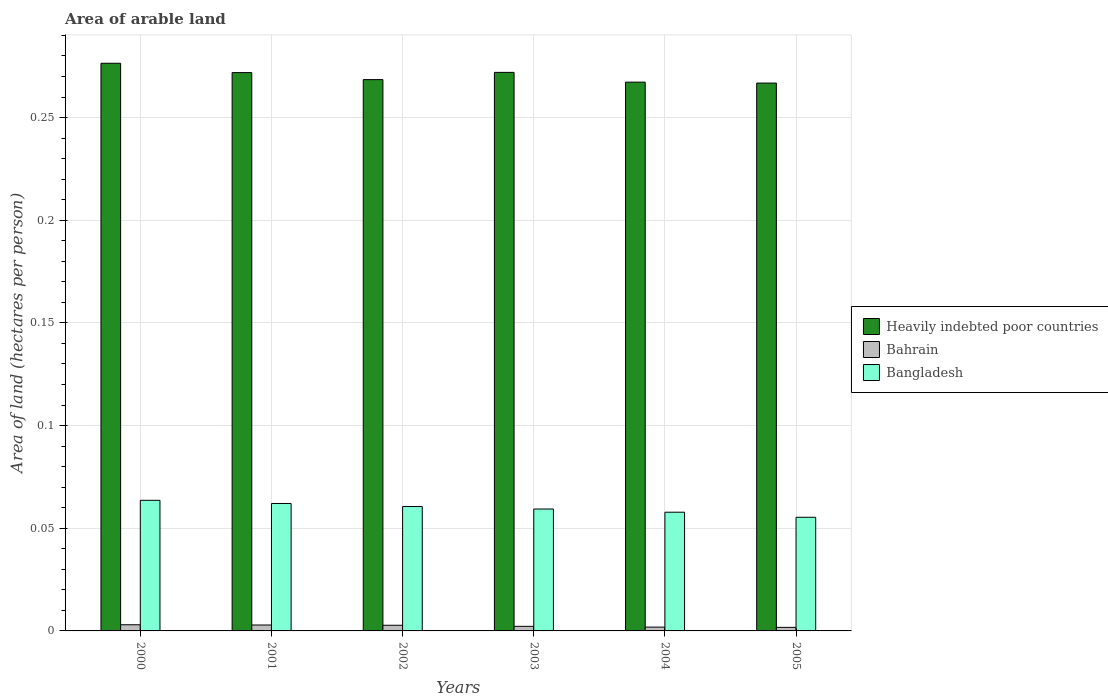How many different coloured bars are there?
Your answer should be compact. 3. How many groups of bars are there?
Make the answer very short. 6. Are the number of bars per tick equal to the number of legend labels?
Ensure brevity in your answer.  Yes. Are the number of bars on each tick of the X-axis equal?
Keep it short and to the point. Yes. What is the label of the 6th group of bars from the left?
Your answer should be very brief. 2005. What is the total arable land in Heavily indebted poor countries in 2001?
Ensure brevity in your answer.  0.27. Across all years, what is the maximum total arable land in Bangladesh?
Your answer should be compact. 0.06. Across all years, what is the minimum total arable land in Bangladesh?
Your answer should be compact. 0.06. In which year was the total arable land in Bahrain minimum?
Your response must be concise. 2005. What is the total total arable land in Heavily indebted poor countries in the graph?
Ensure brevity in your answer.  1.62. What is the difference between the total arable land in Heavily indebted poor countries in 2001 and that in 2002?
Keep it short and to the point. 0. What is the difference between the total arable land in Heavily indebted poor countries in 2000 and the total arable land in Bahrain in 2003?
Your answer should be very brief. 0.27. What is the average total arable land in Bangladesh per year?
Your answer should be compact. 0.06. In the year 2004, what is the difference between the total arable land in Bahrain and total arable land in Heavily indebted poor countries?
Keep it short and to the point. -0.27. What is the ratio of the total arable land in Heavily indebted poor countries in 2001 to that in 2002?
Your answer should be very brief. 1.01. Is the total arable land in Bahrain in 2001 less than that in 2004?
Your answer should be very brief. No. What is the difference between the highest and the second highest total arable land in Bangladesh?
Your response must be concise. 0. What is the difference between the highest and the lowest total arable land in Bahrain?
Give a very brief answer. 0. What does the 3rd bar from the left in 2003 represents?
Your answer should be compact. Bangladesh. Is it the case that in every year, the sum of the total arable land in Bangladesh and total arable land in Heavily indebted poor countries is greater than the total arable land in Bahrain?
Offer a terse response. Yes. Are the values on the major ticks of Y-axis written in scientific E-notation?
Provide a succinct answer. No. Does the graph contain any zero values?
Your answer should be very brief. No. Where does the legend appear in the graph?
Give a very brief answer. Center right. How are the legend labels stacked?
Keep it short and to the point. Vertical. What is the title of the graph?
Offer a terse response. Area of arable land. Does "St. Vincent and the Grenadines" appear as one of the legend labels in the graph?
Make the answer very short. No. What is the label or title of the X-axis?
Provide a short and direct response. Years. What is the label or title of the Y-axis?
Offer a very short reply. Area of land (hectares per person). What is the Area of land (hectares per person) in Heavily indebted poor countries in 2000?
Your response must be concise. 0.28. What is the Area of land (hectares per person) of Bahrain in 2000?
Your answer should be very brief. 0. What is the Area of land (hectares per person) of Bangladesh in 2000?
Your answer should be compact. 0.06. What is the Area of land (hectares per person) of Heavily indebted poor countries in 2001?
Your answer should be very brief. 0.27. What is the Area of land (hectares per person) in Bahrain in 2001?
Keep it short and to the point. 0. What is the Area of land (hectares per person) in Bangladesh in 2001?
Your answer should be very brief. 0.06. What is the Area of land (hectares per person) in Heavily indebted poor countries in 2002?
Your answer should be compact. 0.27. What is the Area of land (hectares per person) in Bahrain in 2002?
Keep it short and to the point. 0. What is the Area of land (hectares per person) of Bangladesh in 2002?
Provide a succinct answer. 0.06. What is the Area of land (hectares per person) in Heavily indebted poor countries in 2003?
Provide a succinct answer. 0.27. What is the Area of land (hectares per person) in Bahrain in 2003?
Offer a very short reply. 0. What is the Area of land (hectares per person) in Bangladesh in 2003?
Provide a succinct answer. 0.06. What is the Area of land (hectares per person) of Heavily indebted poor countries in 2004?
Offer a terse response. 0.27. What is the Area of land (hectares per person) of Bahrain in 2004?
Give a very brief answer. 0. What is the Area of land (hectares per person) of Bangladesh in 2004?
Your response must be concise. 0.06. What is the Area of land (hectares per person) of Heavily indebted poor countries in 2005?
Make the answer very short. 0.27. What is the Area of land (hectares per person) of Bahrain in 2005?
Provide a short and direct response. 0. What is the Area of land (hectares per person) in Bangladesh in 2005?
Provide a succinct answer. 0.06. Across all years, what is the maximum Area of land (hectares per person) in Heavily indebted poor countries?
Provide a succinct answer. 0.28. Across all years, what is the maximum Area of land (hectares per person) of Bahrain?
Ensure brevity in your answer.  0. Across all years, what is the maximum Area of land (hectares per person) of Bangladesh?
Give a very brief answer. 0.06. Across all years, what is the minimum Area of land (hectares per person) in Heavily indebted poor countries?
Give a very brief answer. 0.27. Across all years, what is the minimum Area of land (hectares per person) of Bahrain?
Give a very brief answer. 0. Across all years, what is the minimum Area of land (hectares per person) in Bangladesh?
Ensure brevity in your answer.  0.06. What is the total Area of land (hectares per person) in Heavily indebted poor countries in the graph?
Make the answer very short. 1.62. What is the total Area of land (hectares per person) of Bahrain in the graph?
Your response must be concise. 0.01. What is the total Area of land (hectares per person) of Bangladesh in the graph?
Offer a terse response. 0.36. What is the difference between the Area of land (hectares per person) of Heavily indebted poor countries in 2000 and that in 2001?
Keep it short and to the point. 0. What is the difference between the Area of land (hectares per person) in Bahrain in 2000 and that in 2001?
Your answer should be compact. 0. What is the difference between the Area of land (hectares per person) in Bangladesh in 2000 and that in 2001?
Provide a short and direct response. 0. What is the difference between the Area of land (hectares per person) of Heavily indebted poor countries in 2000 and that in 2002?
Your answer should be compact. 0.01. What is the difference between the Area of land (hectares per person) in Bahrain in 2000 and that in 2002?
Provide a short and direct response. 0. What is the difference between the Area of land (hectares per person) of Bangladesh in 2000 and that in 2002?
Keep it short and to the point. 0. What is the difference between the Area of land (hectares per person) in Heavily indebted poor countries in 2000 and that in 2003?
Offer a very short reply. 0. What is the difference between the Area of land (hectares per person) in Bahrain in 2000 and that in 2003?
Offer a terse response. 0. What is the difference between the Area of land (hectares per person) of Bangladesh in 2000 and that in 2003?
Your answer should be very brief. 0. What is the difference between the Area of land (hectares per person) in Heavily indebted poor countries in 2000 and that in 2004?
Make the answer very short. 0.01. What is the difference between the Area of land (hectares per person) of Bahrain in 2000 and that in 2004?
Provide a succinct answer. 0. What is the difference between the Area of land (hectares per person) in Bangladesh in 2000 and that in 2004?
Your answer should be compact. 0.01. What is the difference between the Area of land (hectares per person) in Heavily indebted poor countries in 2000 and that in 2005?
Offer a very short reply. 0.01. What is the difference between the Area of land (hectares per person) of Bahrain in 2000 and that in 2005?
Provide a short and direct response. 0. What is the difference between the Area of land (hectares per person) of Bangladesh in 2000 and that in 2005?
Offer a very short reply. 0.01. What is the difference between the Area of land (hectares per person) in Heavily indebted poor countries in 2001 and that in 2002?
Your answer should be very brief. 0. What is the difference between the Area of land (hectares per person) in Bangladesh in 2001 and that in 2002?
Offer a terse response. 0. What is the difference between the Area of land (hectares per person) of Heavily indebted poor countries in 2001 and that in 2003?
Keep it short and to the point. -0. What is the difference between the Area of land (hectares per person) in Bahrain in 2001 and that in 2003?
Provide a succinct answer. 0. What is the difference between the Area of land (hectares per person) in Bangladesh in 2001 and that in 2003?
Give a very brief answer. 0. What is the difference between the Area of land (hectares per person) of Heavily indebted poor countries in 2001 and that in 2004?
Make the answer very short. 0. What is the difference between the Area of land (hectares per person) of Bangladesh in 2001 and that in 2004?
Offer a very short reply. 0. What is the difference between the Area of land (hectares per person) of Heavily indebted poor countries in 2001 and that in 2005?
Ensure brevity in your answer.  0.01. What is the difference between the Area of land (hectares per person) of Bahrain in 2001 and that in 2005?
Your answer should be very brief. 0. What is the difference between the Area of land (hectares per person) in Bangladesh in 2001 and that in 2005?
Keep it short and to the point. 0.01. What is the difference between the Area of land (hectares per person) in Heavily indebted poor countries in 2002 and that in 2003?
Ensure brevity in your answer.  -0. What is the difference between the Area of land (hectares per person) in Bahrain in 2002 and that in 2003?
Give a very brief answer. 0. What is the difference between the Area of land (hectares per person) of Bangladesh in 2002 and that in 2003?
Your answer should be compact. 0. What is the difference between the Area of land (hectares per person) in Heavily indebted poor countries in 2002 and that in 2004?
Make the answer very short. 0. What is the difference between the Area of land (hectares per person) of Bahrain in 2002 and that in 2004?
Your answer should be compact. 0. What is the difference between the Area of land (hectares per person) of Bangladesh in 2002 and that in 2004?
Your answer should be compact. 0. What is the difference between the Area of land (hectares per person) of Heavily indebted poor countries in 2002 and that in 2005?
Provide a short and direct response. 0. What is the difference between the Area of land (hectares per person) of Bangladesh in 2002 and that in 2005?
Give a very brief answer. 0.01. What is the difference between the Area of land (hectares per person) in Heavily indebted poor countries in 2003 and that in 2004?
Your answer should be very brief. 0. What is the difference between the Area of land (hectares per person) of Bahrain in 2003 and that in 2004?
Provide a short and direct response. 0. What is the difference between the Area of land (hectares per person) in Bangladesh in 2003 and that in 2004?
Offer a terse response. 0. What is the difference between the Area of land (hectares per person) of Heavily indebted poor countries in 2003 and that in 2005?
Your answer should be very brief. 0.01. What is the difference between the Area of land (hectares per person) in Bahrain in 2003 and that in 2005?
Offer a very short reply. 0. What is the difference between the Area of land (hectares per person) in Bangladesh in 2003 and that in 2005?
Make the answer very short. 0. What is the difference between the Area of land (hectares per person) of Heavily indebted poor countries in 2004 and that in 2005?
Ensure brevity in your answer.  0. What is the difference between the Area of land (hectares per person) of Bangladesh in 2004 and that in 2005?
Your answer should be very brief. 0. What is the difference between the Area of land (hectares per person) in Heavily indebted poor countries in 2000 and the Area of land (hectares per person) in Bahrain in 2001?
Your response must be concise. 0.27. What is the difference between the Area of land (hectares per person) of Heavily indebted poor countries in 2000 and the Area of land (hectares per person) of Bangladesh in 2001?
Your answer should be very brief. 0.21. What is the difference between the Area of land (hectares per person) of Bahrain in 2000 and the Area of land (hectares per person) of Bangladesh in 2001?
Offer a terse response. -0.06. What is the difference between the Area of land (hectares per person) in Heavily indebted poor countries in 2000 and the Area of land (hectares per person) in Bahrain in 2002?
Make the answer very short. 0.27. What is the difference between the Area of land (hectares per person) in Heavily indebted poor countries in 2000 and the Area of land (hectares per person) in Bangladesh in 2002?
Provide a succinct answer. 0.22. What is the difference between the Area of land (hectares per person) in Bahrain in 2000 and the Area of land (hectares per person) in Bangladesh in 2002?
Your answer should be very brief. -0.06. What is the difference between the Area of land (hectares per person) of Heavily indebted poor countries in 2000 and the Area of land (hectares per person) of Bahrain in 2003?
Your answer should be compact. 0.27. What is the difference between the Area of land (hectares per person) of Heavily indebted poor countries in 2000 and the Area of land (hectares per person) of Bangladesh in 2003?
Offer a very short reply. 0.22. What is the difference between the Area of land (hectares per person) in Bahrain in 2000 and the Area of land (hectares per person) in Bangladesh in 2003?
Ensure brevity in your answer.  -0.06. What is the difference between the Area of land (hectares per person) of Heavily indebted poor countries in 2000 and the Area of land (hectares per person) of Bahrain in 2004?
Offer a very short reply. 0.27. What is the difference between the Area of land (hectares per person) in Heavily indebted poor countries in 2000 and the Area of land (hectares per person) in Bangladesh in 2004?
Give a very brief answer. 0.22. What is the difference between the Area of land (hectares per person) in Bahrain in 2000 and the Area of land (hectares per person) in Bangladesh in 2004?
Ensure brevity in your answer.  -0.05. What is the difference between the Area of land (hectares per person) in Heavily indebted poor countries in 2000 and the Area of land (hectares per person) in Bahrain in 2005?
Provide a succinct answer. 0.27. What is the difference between the Area of land (hectares per person) in Heavily indebted poor countries in 2000 and the Area of land (hectares per person) in Bangladesh in 2005?
Your answer should be compact. 0.22. What is the difference between the Area of land (hectares per person) in Bahrain in 2000 and the Area of land (hectares per person) in Bangladesh in 2005?
Provide a succinct answer. -0.05. What is the difference between the Area of land (hectares per person) in Heavily indebted poor countries in 2001 and the Area of land (hectares per person) in Bahrain in 2002?
Your answer should be compact. 0.27. What is the difference between the Area of land (hectares per person) of Heavily indebted poor countries in 2001 and the Area of land (hectares per person) of Bangladesh in 2002?
Keep it short and to the point. 0.21. What is the difference between the Area of land (hectares per person) of Bahrain in 2001 and the Area of land (hectares per person) of Bangladesh in 2002?
Make the answer very short. -0.06. What is the difference between the Area of land (hectares per person) in Heavily indebted poor countries in 2001 and the Area of land (hectares per person) in Bahrain in 2003?
Your answer should be compact. 0.27. What is the difference between the Area of land (hectares per person) of Heavily indebted poor countries in 2001 and the Area of land (hectares per person) of Bangladesh in 2003?
Keep it short and to the point. 0.21. What is the difference between the Area of land (hectares per person) in Bahrain in 2001 and the Area of land (hectares per person) in Bangladesh in 2003?
Your response must be concise. -0.06. What is the difference between the Area of land (hectares per person) of Heavily indebted poor countries in 2001 and the Area of land (hectares per person) of Bahrain in 2004?
Keep it short and to the point. 0.27. What is the difference between the Area of land (hectares per person) of Heavily indebted poor countries in 2001 and the Area of land (hectares per person) of Bangladesh in 2004?
Keep it short and to the point. 0.21. What is the difference between the Area of land (hectares per person) of Bahrain in 2001 and the Area of land (hectares per person) of Bangladesh in 2004?
Your response must be concise. -0.05. What is the difference between the Area of land (hectares per person) in Heavily indebted poor countries in 2001 and the Area of land (hectares per person) in Bahrain in 2005?
Offer a very short reply. 0.27. What is the difference between the Area of land (hectares per person) in Heavily indebted poor countries in 2001 and the Area of land (hectares per person) in Bangladesh in 2005?
Give a very brief answer. 0.22. What is the difference between the Area of land (hectares per person) of Bahrain in 2001 and the Area of land (hectares per person) of Bangladesh in 2005?
Offer a very short reply. -0.05. What is the difference between the Area of land (hectares per person) in Heavily indebted poor countries in 2002 and the Area of land (hectares per person) in Bahrain in 2003?
Offer a very short reply. 0.27. What is the difference between the Area of land (hectares per person) of Heavily indebted poor countries in 2002 and the Area of land (hectares per person) of Bangladesh in 2003?
Provide a short and direct response. 0.21. What is the difference between the Area of land (hectares per person) of Bahrain in 2002 and the Area of land (hectares per person) of Bangladesh in 2003?
Make the answer very short. -0.06. What is the difference between the Area of land (hectares per person) in Heavily indebted poor countries in 2002 and the Area of land (hectares per person) in Bahrain in 2004?
Your response must be concise. 0.27. What is the difference between the Area of land (hectares per person) in Heavily indebted poor countries in 2002 and the Area of land (hectares per person) in Bangladesh in 2004?
Keep it short and to the point. 0.21. What is the difference between the Area of land (hectares per person) of Bahrain in 2002 and the Area of land (hectares per person) of Bangladesh in 2004?
Ensure brevity in your answer.  -0.06. What is the difference between the Area of land (hectares per person) of Heavily indebted poor countries in 2002 and the Area of land (hectares per person) of Bahrain in 2005?
Your response must be concise. 0.27. What is the difference between the Area of land (hectares per person) in Heavily indebted poor countries in 2002 and the Area of land (hectares per person) in Bangladesh in 2005?
Your response must be concise. 0.21. What is the difference between the Area of land (hectares per person) of Bahrain in 2002 and the Area of land (hectares per person) of Bangladesh in 2005?
Provide a short and direct response. -0.05. What is the difference between the Area of land (hectares per person) in Heavily indebted poor countries in 2003 and the Area of land (hectares per person) in Bahrain in 2004?
Your response must be concise. 0.27. What is the difference between the Area of land (hectares per person) in Heavily indebted poor countries in 2003 and the Area of land (hectares per person) in Bangladesh in 2004?
Your response must be concise. 0.21. What is the difference between the Area of land (hectares per person) in Bahrain in 2003 and the Area of land (hectares per person) in Bangladesh in 2004?
Provide a short and direct response. -0.06. What is the difference between the Area of land (hectares per person) of Heavily indebted poor countries in 2003 and the Area of land (hectares per person) of Bahrain in 2005?
Your answer should be compact. 0.27. What is the difference between the Area of land (hectares per person) of Heavily indebted poor countries in 2003 and the Area of land (hectares per person) of Bangladesh in 2005?
Make the answer very short. 0.22. What is the difference between the Area of land (hectares per person) in Bahrain in 2003 and the Area of land (hectares per person) in Bangladesh in 2005?
Offer a very short reply. -0.05. What is the difference between the Area of land (hectares per person) in Heavily indebted poor countries in 2004 and the Area of land (hectares per person) in Bahrain in 2005?
Provide a succinct answer. 0.27. What is the difference between the Area of land (hectares per person) of Heavily indebted poor countries in 2004 and the Area of land (hectares per person) of Bangladesh in 2005?
Offer a very short reply. 0.21. What is the difference between the Area of land (hectares per person) in Bahrain in 2004 and the Area of land (hectares per person) in Bangladesh in 2005?
Your response must be concise. -0.05. What is the average Area of land (hectares per person) of Heavily indebted poor countries per year?
Offer a very short reply. 0.27. What is the average Area of land (hectares per person) of Bahrain per year?
Ensure brevity in your answer.  0. What is the average Area of land (hectares per person) of Bangladesh per year?
Provide a short and direct response. 0.06. In the year 2000, what is the difference between the Area of land (hectares per person) of Heavily indebted poor countries and Area of land (hectares per person) of Bahrain?
Offer a terse response. 0.27. In the year 2000, what is the difference between the Area of land (hectares per person) in Heavily indebted poor countries and Area of land (hectares per person) in Bangladesh?
Your answer should be very brief. 0.21. In the year 2000, what is the difference between the Area of land (hectares per person) in Bahrain and Area of land (hectares per person) in Bangladesh?
Your response must be concise. -0.06. In the year 2001, what is the difference between the Area of land (hectares per person) of Heavily indebted poor countries and Area of land (hectares per person) of Bahrain?
Offer a terse response. 0.27. In the year 2001, what is the difference between the Area of land (hectares per person) of Heavily indebted poor countries and Area of land (hectares per person) of Bangladesh?
Make the answer very short. 0.21. In the year 2001, what is the difference between the Area of land (hectares per person) in Bahrain and Area of land (hectares per person) in Bangladesh?
Keep it short and to the point. -0.06. In the year 2002, what is the difference between the Area of land (hectares per person) in Heavily indebted poor countries and Area of land (hectares per person) in Bahrain?
Your answer should be very brief. 0.27. In the year 2002, what is the difference between the Area of land (hectares per person) in Heavily indebted poor countries and Area of land (hectares per person) in Bangladesh?
Your response must be concise. 0.21. In the year 2002, what is the difference between the Area of land (hectares per person) in Bahrain and Area of land (hectares per person) in Bangladesh?
Provide a succinct answer. -0.06. In the year 2003, what is the difference between the Area of land (hectares per person) in Heavily indebted poor countries and Area of land (hectares per person) in Bahrain?
Offer a terse response. 0.27. In the year 2003, what is the difference between the Area of land (hectares per person) of Heavily indebted poor countries and Area of land (hectares per person) of Bangladesh?
Your answer should be compact. 0.21. In the year 2003, what is the difference between the Area of land (hectares per person) of Bahrain and Area of land (hectares per person) of Bangladesh?
Ensure brevity in your answer.  -0.06. In the year 2004, what is the difference between the Area of land (hectares per person) in Heavily indebted poor countries and Area of land (hectares per person) in Bahrain?
Your response must be concise. 0.27. In the year 2004, what is the difference between the Area of land (hectares per person) of Heavily indebted poor countries and Area of land (hectares per person) of Bangladesh?
Provide a succinct answer. 0.21. In the year 2004, what is the difference between the Area of land (hectares per person) of Bahrain and Area of land (hectares per person) of Bangladesh?
Ensure brevity in your answer.  -0.06. In the year 2005, what is the difference between the Area of land (hectares per person) in Heavily indebted poor countries and Area of land (hectares per person) in Bahrain?
Provide a short and direct response. 0.27. In the year 2005, what is the difference between the Area of land (hectares per person) of Heavily indebted poor countries and Area of land (hectares per person) of Bangladesh?
Provide a short and direct response. 0.21. In the year 2005, what is the difference between the Area of land (hectares per person) of Bahrain and Area of land (hectares per person) of Bangladesh?
Make the answer very short. -0.05. What is the ratio of the Area of land (hectares per person) in Heavily indebted poor countries in 2000 to that in 2001?
Provide a short and direct response. 1.02. What is the ratio of the Area of land (hectares per person) of Bahrain in 2000 to that in 2001?
Offer a very short reply. 1.04. What is the ratio of the Area of land (hectares per person) in Bangladesh in 2000 to that in 2001?
Provide a short and direct response. 1.02. What is the ratio of the Area of land (hectares per person) of Heavily indebted poor countries in 2000 to that in 2002?
Offer a terse response. 1.03. What is the ratio of the Area of land (hectares per person) in Bahrain in 2000 to that in 2002?
Ensure brevity in your answer.  1.09. What is the ratio of the Area of land (hectares per person) in Bangladesh in 2000 to that in 2002?
Your answer should be compact. 1.05. What is the ratio of the Area of land (hectares per person) of Heavily indebted poor countries in 2000 to that in 2003?
Your answer should be very brief. 1.02. What is the ratio of the Area of land (hectares per person) in Bahrain in 2000 to that in 2003?
Your answer should be very brief. 1.34. What is the ratio of the Area of land (hectares per person) in Bangladesh in 2000 to that in 2003?
Your answer should be very brief. 1.07. What is the ratio of the Area of land (hectares per person) in Heavily indebted poor countries in 2000 to that in 2004?
Your answer should be very brief. 1.03. What is the ratio of the Area of land (hectares per person) of Bahrain in 2000 to that in 2004?
Ensure brevity in your answer.  1.62. What is the ratio of the Area of land (hectares per person) of Bangladesh in 2000 to that in 2004?
Your answer should be very brief. 1.1. What is the ratio of the Area of land (hectares per person) of Heavily indebted poor countries in 2000 to that in 2005?
Provide a succinct answer. 1.04. What is the ratio of the Area of land (hectares per person) in Bahrain in 2000 to that in 2005?
Provide a short and direct response. 1.73. What is the ratio of the Area of land (hectares per person) of Bangladesh in 2000 to that in 2005?
Keep it short and to the point. 1.15. What is the ratio of the Area of land (hectares per person) of Heavily indebted poor countries in 2001 to that in 2002?
Provide a short and direct response. 1.01. What is the ratio of the Area of land (hectares per person) of Bahrain in 2001 to that in 2002?
Your answer should be very brief. 1.04. What is the ratio of the Area of land (hectares per person) in Bangladesh in 2001 to that in 2002?
Ensure brevity in your answer.  1.02. What is the ratio of the Area of land (hectares per person) of Bahrain in 2001 to that in 2003?
Your answer should be compact. 1.29. What is the ratio of the Area of land (hectares per person) in Bangladesh in 2001 to that in 2003?
Provide a short and direct response. 1.05. What is the ratio of the Area of land (hectares per person) in Heavily indebted poor countries in 2001 to that in 2004?
Your answer should be very brief. 1.02. What is the ratio of the Area of land (hectares per person) of Bahrain in 2001 to that in 2004?
Your answer should be very brief. 1.55. What is the ratio of the Area of land (hectares per person) of Bangladesh in 2001 to that in 2004?
Provide a short and direct response. 1.07. What is the ratio of the Area of land (hectares per person) of Heavily indebted poor countries in 2001 to that in 2005?
Your answer should be very brief. 1.02. What is the ratio of the Area of land (hectares per person) of Bahrain in 2001 to that in 2005?
Your response must be concise. 1.66. What is the ratio of the Area of land (hectares per person) in Bangladesh in 2001 to that in 2005?
Offer a terse response. 1.12. What is the ratio of the Area of land (hectares per person) of Heavily indebted poor countries in 2002 to that in 2003?
Provide a short and direct response. 0.99. What is the ratio of the Area of land (hectares per person) of Bahrain in 2002 to that in 2003?
Offer a terse response. 1.24. What is the ratio of the Area of land (hectares per person) of Bangladesh in 2002 to that in 2003?
Your response must be concise. 1.02. What is the ratio of the Area of land (hectares per person) of Heavily indebted poor countries in 2002 to that in 2004?
Your answer should be compact. 1. What is the ratio of the Area of land (hectares per person) in Bahrain in 2002 to that in 2004?
Ensure brevity in your answer.  1.49. What is the ratio of the Area of land (hectares per person) of Bangladesh in 2002 to that in 2004?
Keep it short and to the point. 1.05. What is the ratio of the Area of land (hectares per person) of Heavily indebted poor countries in 2002 to that in 2005?
Your response must be concise. 1.01. What is the ratio of the Area of land (hectares per person) of Bahrain in 2002 to that in 2005?
Ensure brevity in your answer.  1.59. What is the ratio of the Area of land (hectares per person) of Bangladesh in 2002 to that in 2005?
Offer a very short reply. 1.09. What is the ratio of the Area of land (hectares per person) in Heavily indebted poor countries in 2003 to that in 2004?
Make the answer very short. 1.02. What is the ratio of the Area of land (hectares per person) of Bahrain in 2003 to that in 2004?
Ensure brevity in your answer.  1.2. What is the ratio of the Area of land (hectares per person) of Bangladesh in 2003 to that in 2004?
Provide a short and direct response. 1.03. What is the ratio of the Area of land (hectares per person) of Heavily indebted poor countries in 2003 to that in 2005?
Ensure brevity in your answer.  1.02. What is the ratio of the Area of land (hectares per person) of Bahrain in 2003 to that in 2005?
Your response must be concise. 1.29. What is the ratio of the Area of land (hectares per person) in Bangladesh in 2003 to that in 2005?
Provide a succinct answer. 1.07. What is the ratio of the Area of land (hectares per person) in Heavily indebted poor countries in 2004 to that in 2005?
Give a very brief answer. 1. What is the ratio of the Area of land (hectares per person) of Bahrain in 2004 to that in 2005?
Offer a terse response. 1.07. What is the ratio of the Area of land (hectares per person) in Bangladesh in 2004 to that in 2005?
Offer a terse response. 1.04. What is the difference between the highest and the second highest Area of land (hectares per person) of Heavily indebted poor countries?
Your answer should be compact. 0. What is the difference between the highest and the second highest Area of land (hectares per person) in Bahrain?
Your response must be concise. 0. What is the difference between the highest and the second highest Area of land (hectares per person) in Bangladesh?
Keep it short and to the point. 0. What is the difference between the highest and the lowest Area of land (hectares per person) of Heavily indebted poor countries?
Your answer should be compact. 0.01. What is the difference between the highest and the lowest Area of land (hectares per person) of Bahrain?
Make the answer very short. 0. What is the difference between the highest and the lowest Area of land (hectares per person) of Bangladesh?
Offer a very short reply. 0.01. 